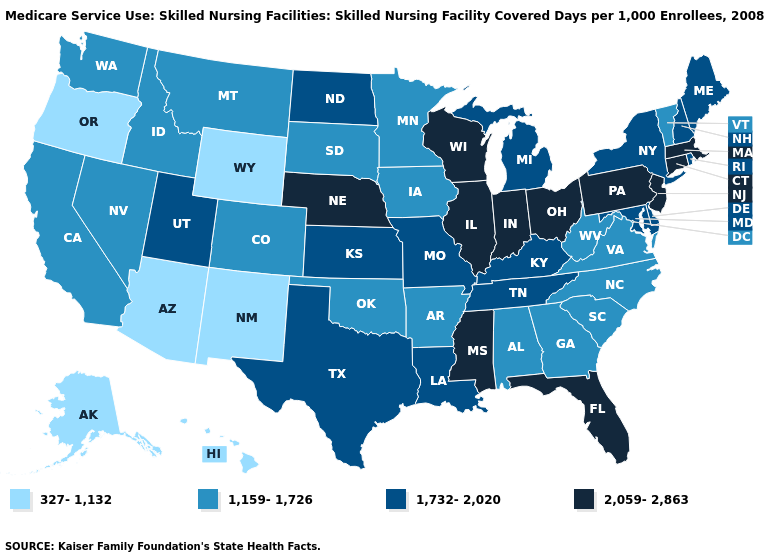Name the states that have a value in the range 327-1,132?
Be succinct. Alaska, Arizona, Hawaii, New Mexico, Oregon, Wyoming. Name the states that have a value in the range 2,059-2,863?
Concise answer only. Connecticut, Florida, Illinois, Indiana, Massachusetts, Mississippi, Nebraska, New Jersey, Ohio, Pennsylvania, Wisconsin. Does Nevada have the same value as Colorado?
Answer briefly. Yes. Name the states that have a value in the range 2,059-2,863?
Concise answer only. Connecticut, Florida, Illinois, Indiana, Massachusetts, Mississippi, Nebraska, New Jersey, Ohio, Pennsylvania, Wisconsin. Which states have the lowest value in the West?
Give a very brief answer. Alaska, Arizona, Hawaii, New Mexico, Oregon, Wyoming. Name the states that have a value in the range 1,159-1,726?
Short answer required. Alabama, Arkansas, California, Colorado, Georgia, Idaho, Iowa, Minnesota, Montana, Nevada, North Carolina, Oklahoma, South Carolina, South Dakota, Vermont, Virginia, Washington, West Virginia. What is the value of Nebraska?
Quick response, please. 2,059-2,863. What is the value of Vermont?
Give a very brief answer. 1,159-1,726. Name the states that have a value in the range 2,059-2,863?
Concise answer only. Connecticut, Florida, Illinois, Indiana, Massachusetts, Mississippi, Nebraska, New Jersey, Ohio, Pennsylvania, Wisconsin. How many symbols are there in the legend?
Answer briefly. 4. Does Washington have the highest value in the USA?
Short answer required. No. What is the value of Minnesota?
Write a very short answer. 1,159-1,726. Does the first symbol in the legend represent the smallest category?
Short answer required. Yes. Does New York have a higher value than Idaho?
Concise answer only. Yes. What is the value of Tennessee?
Quick response, please. 1,732-2,020. 